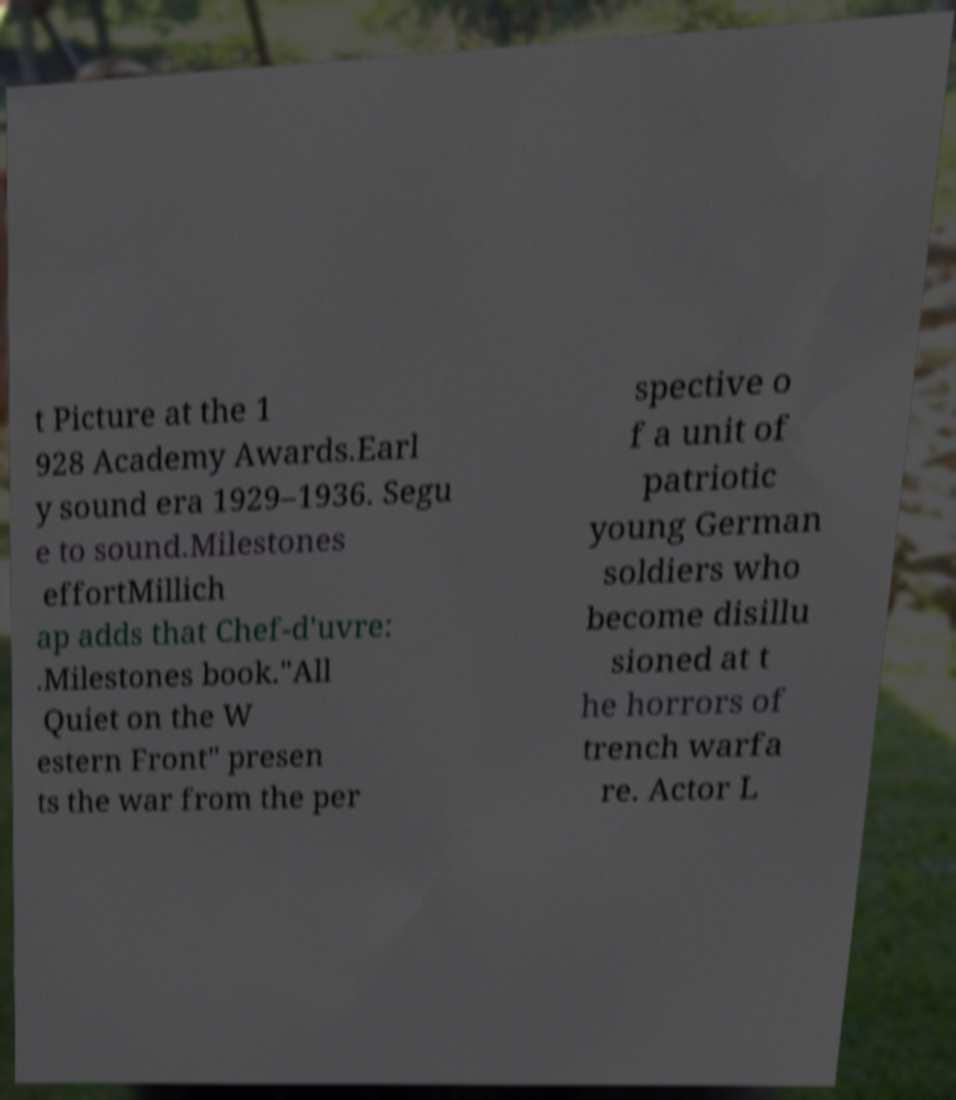For documentation purposes, I need the text within this image transcribed. Could you provide that? t Picture at the 1 928 Academy Awards.Earl y sound era 1929–1936. Segu e to sound.Milestones effortMillich ap adds that Chef-d'uvre: .Milestones book."All Quiet on the W estern Front" presen ts the war from the per spective o f a unit of patriotic young German soldiers who become disillu sioned at t he horrors of trench warfa re. Actor L 